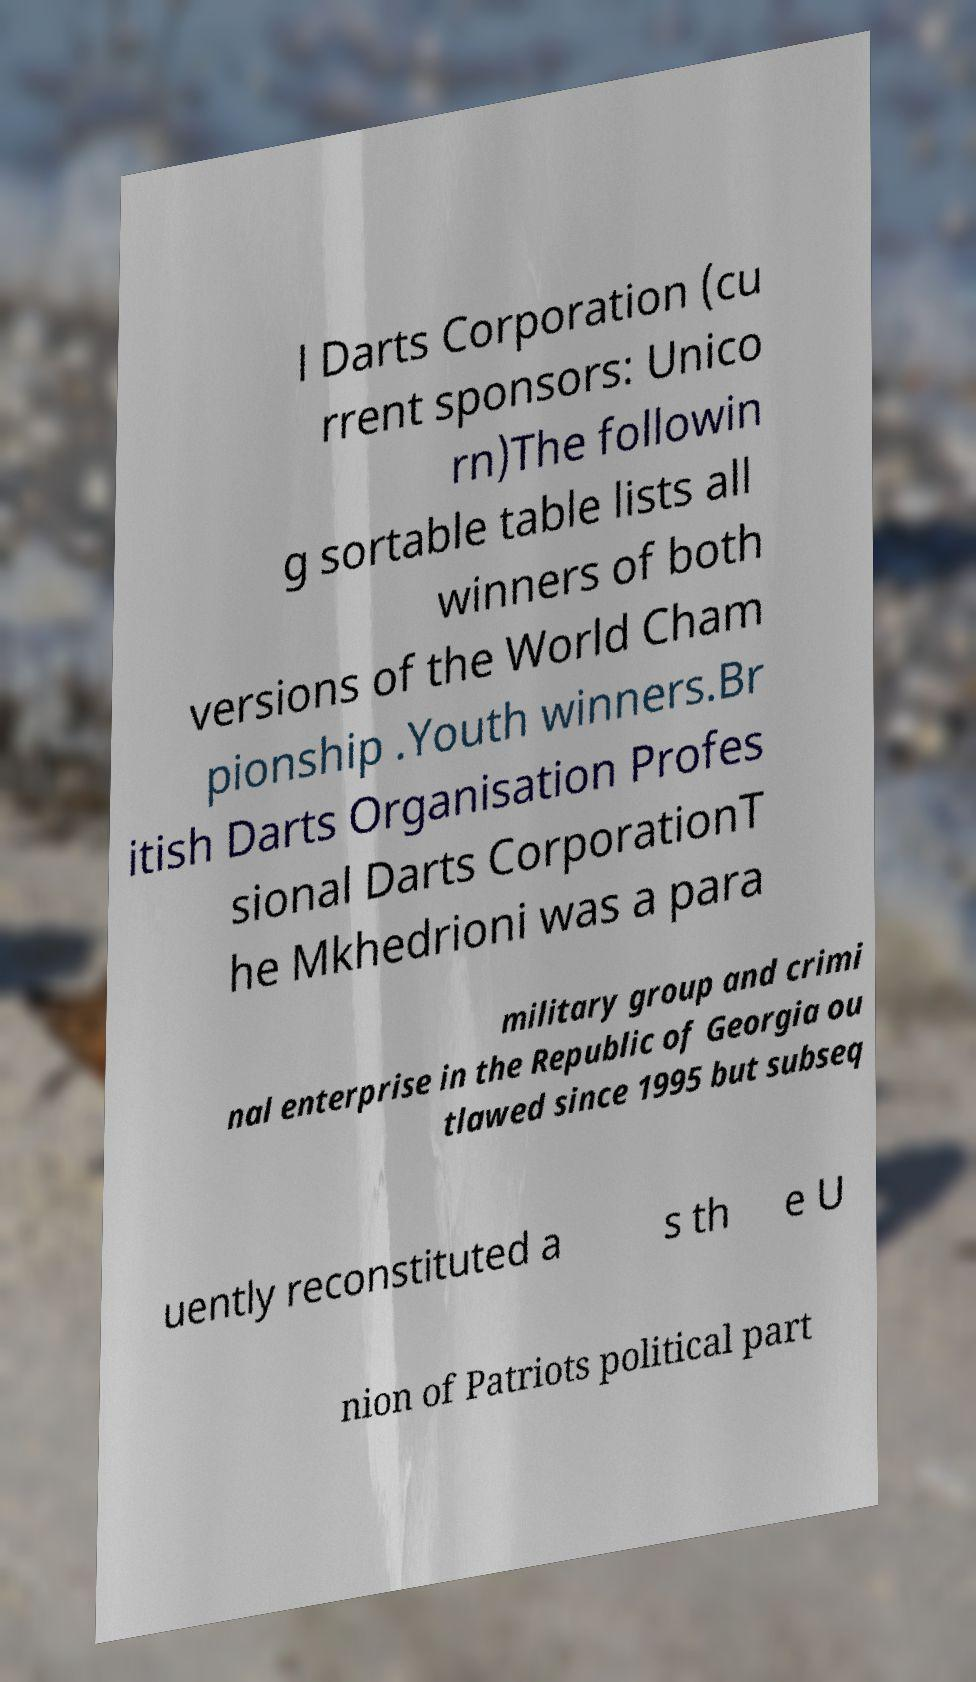Can you accurately transcribe the text from the provided image for me? l Darts Corporation (cu rrent sponsors: Unico rn)The followin g sortable table lists all winners of both versions of the World Cham pionship .Youth winners.Br itish Darts Organisation Profes sional Darts CorporationT he Mkhedrioni was a para military group and crimi nal enterprise in the Republic of Georgia ou tlawed since 1995 but subseq uently reconstituted a s th e U nion of Patriots political part 